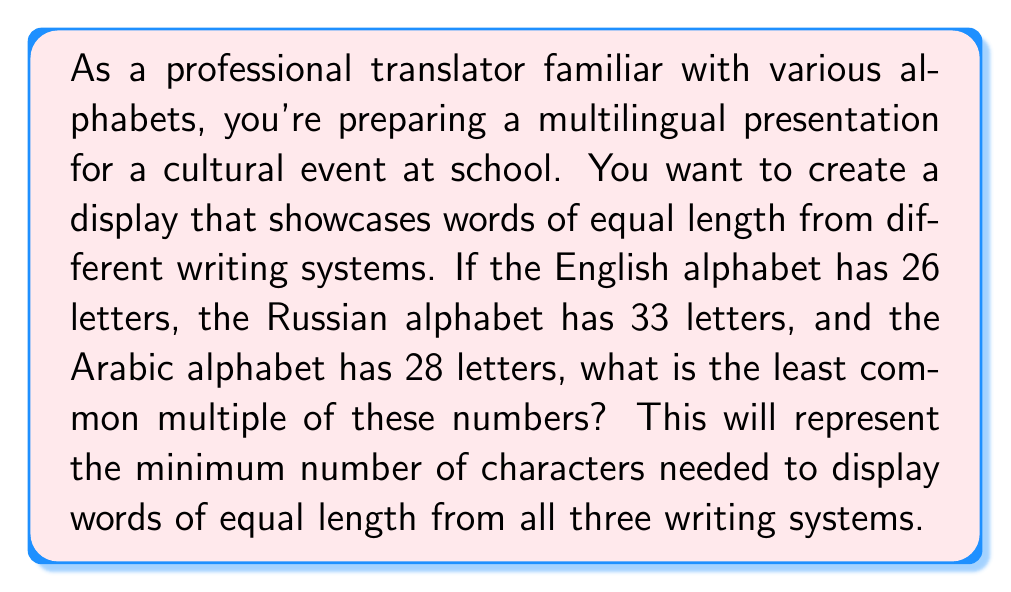Can you answer this question? To find the least common multiple (LCM) of 26, 33, and 28, we'll follow these steps:

1) First, let's find the prime factorization of each number:

   $26 = 2 \times 13$
   $33 = 3 \times 11$
   $28 = 2^2 \times 7$

2) The LCM will include the highest power of each prime factor from these factorizations:

   $LCM(26, 33, 28) = 2^2 \times 3 \times 7 \times 11 \times 13$

3) Now, let's multiply these factors:

   $2^2 = 4$
   $4 \times 3 = 12$
   $12 \times 7 = 84$
   $84 \times 11 = 924$
   $924 \times 13 = 12,012$

Therefore, the least common multiple of 26, 33, and 28 is 12,012.

This means that to display words of equal length from English, Russian, and Arabic alphabets, you would need words that are 462 letters long in English (12,012 ÷ 26), 364 letters long in Russian (12,012 ÷ 33), and 429 letters long in Arabic (12,012 ÷ 28).
Answer: $12,012$ 